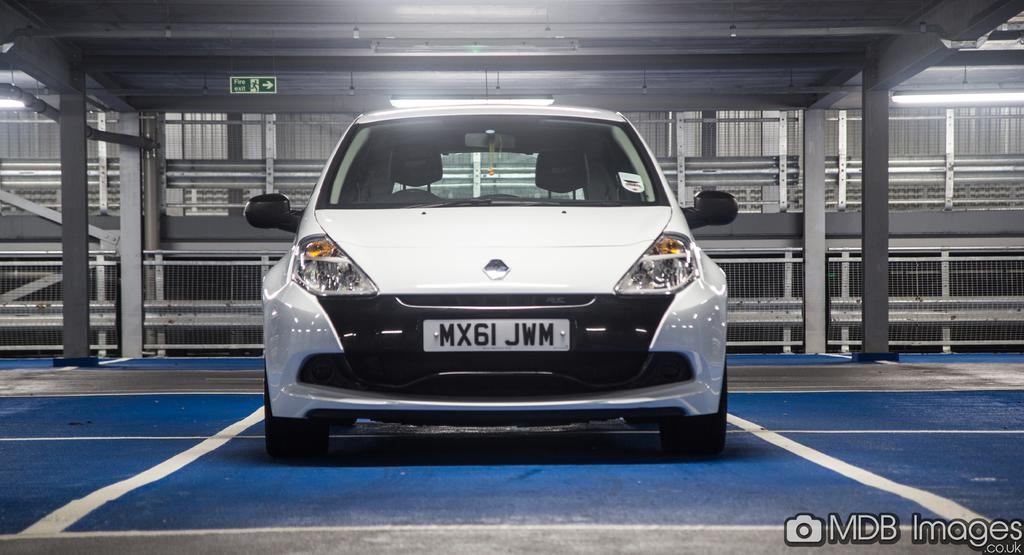What is the main subject in the foreground of the image? There is a car in the foreground of the image. What is the position of the car in the image? The car is on the floor. What can be seen in the background of the image? There is a mesh, a shed-like structure, and a sign board in the background of the image. What is the tendency of the car's friend in the image? There is no indication of a car having a friend in the image, as cars are inanimate objects. 